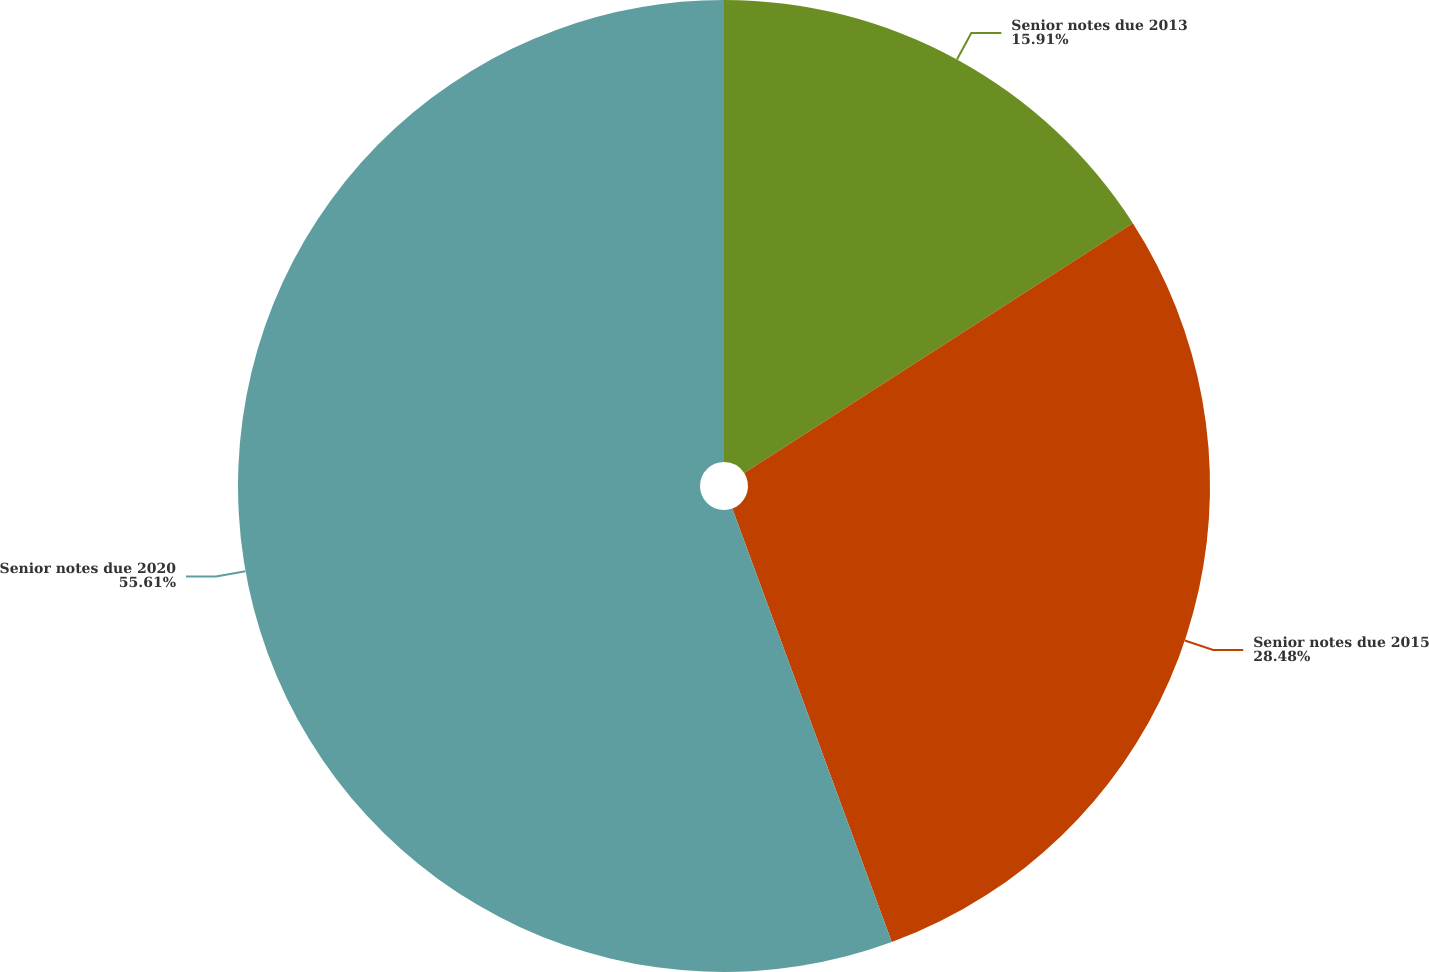Convert chart. <chart><loc_0><loc_0><loc_500><loc_500><pie_chart><fcel>Senior notes due 2013<fcel>Senior notes due 2015<fcel>Senior notes due 2020<nl><fcel>15.91%<fcel>28.48%<fcel>55.61%<nl></chart> 